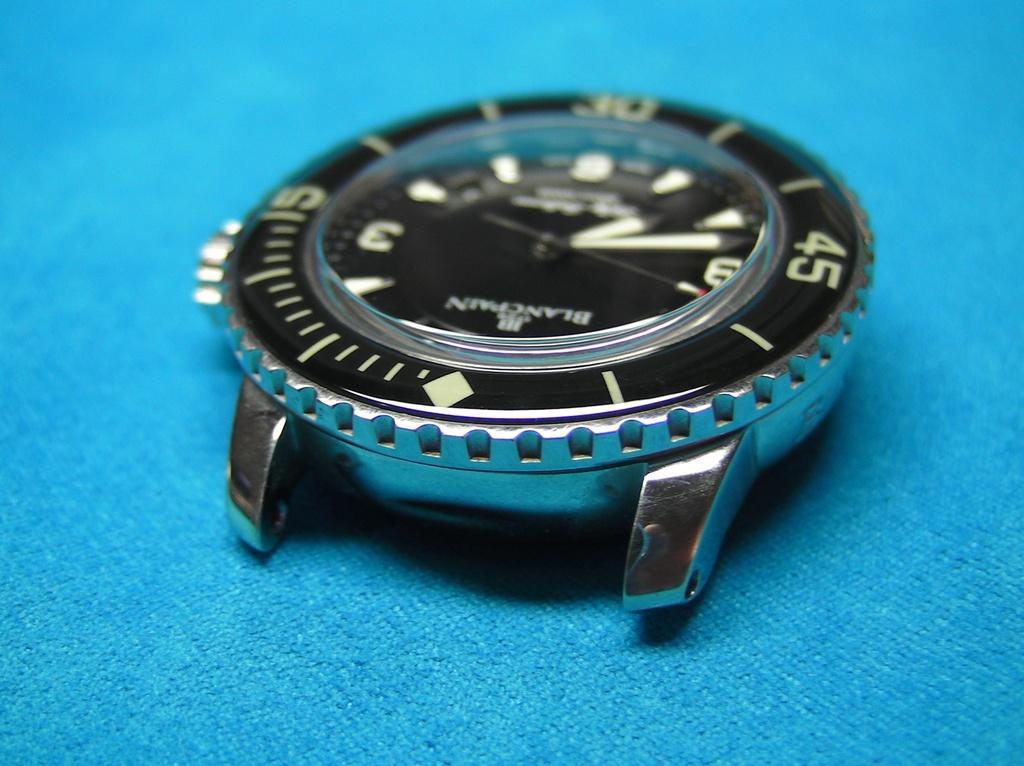What brand of watch is that?
Make the answer very short. Blancpain. Are the numbers on the bezzle divisable by five?
Ensure brevity in your answer.  Yes. 